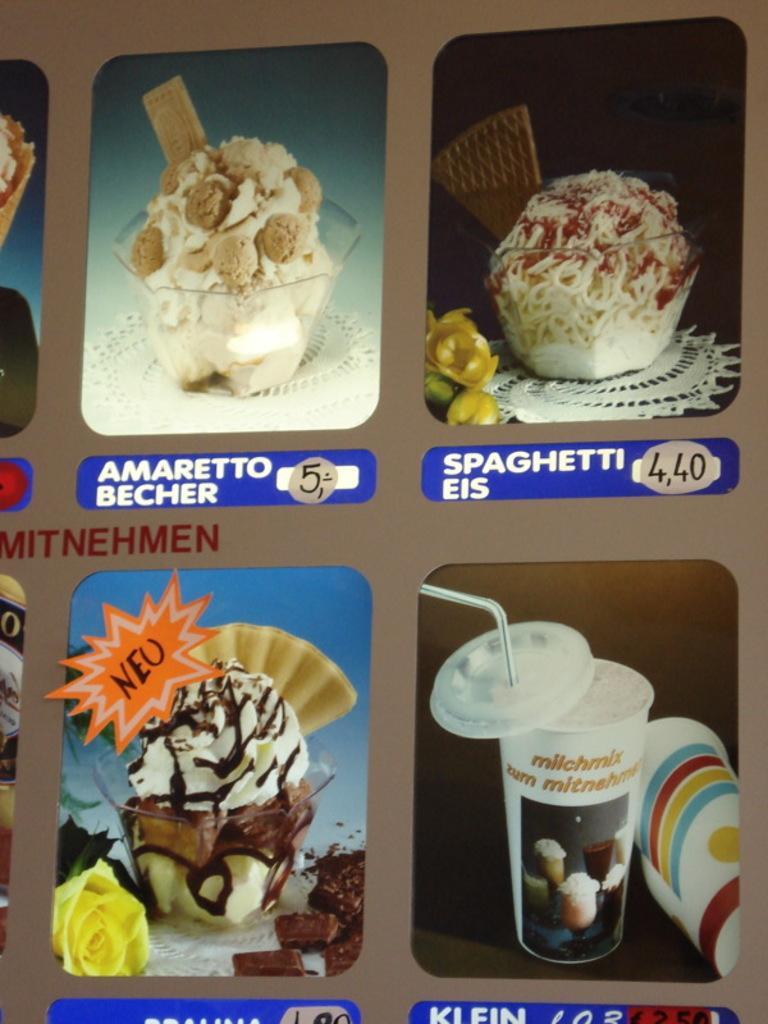Can you describe this image briefly? In this image, we can see there is a poster having images of food items, texts and numbers. And the background is gray in color. 